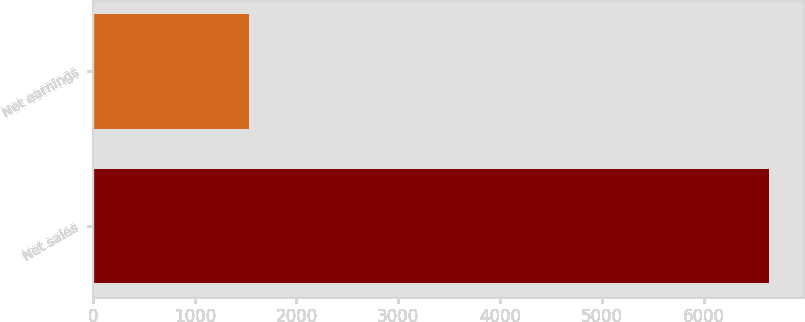Convert chart. <chart><loc_0><loc_0><loc_500><loc_500><bar_chart><fcel>Net sales<fcel>Net earnings<nl><fcel>6642<fcel>1537<nl></chart> 